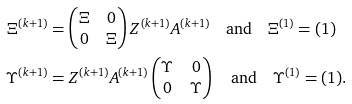Convert formula to latex. <formula><loc_0><loc_0><loc_500><loc_500>\Xi ^ { ( k + 1 ) } & = \begin{pmatrix} \Xi & 0 \\ 0 & \Xi \end{pmatrix} Z ^ { ( k + 1 ) } A ^ { ( k + 1 ) } \quad \text {and} \quad \Xi ^ { ( 1 ) } = ( 1 ) \\ \Upsilon ^ { ( k + 1 ) } & = Z ^ { ( k + 1 ) } A ^ { ( k + 1 ) } \begin{pmatrix} \Upsilon & 0 \\ 0 & \Upsilon \end{pmatrix} \quad \text {and} \quad \Upsilon ^ { ( 1 ) } = ( 1 ) .</formula> 